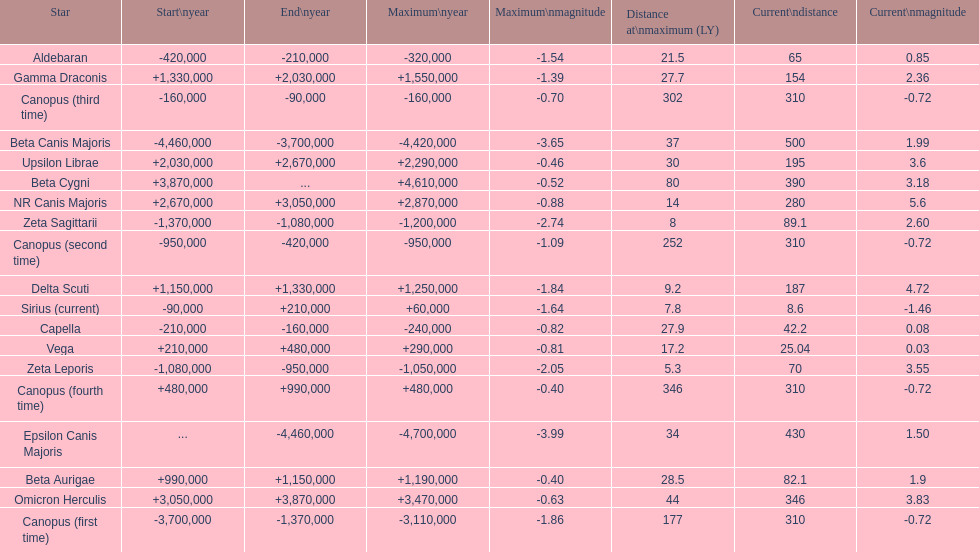What is the only star with a distance at maximum of 80? Beta Cygni. 